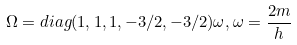<formula> <loc_0><loc_0><loc_500><loc_500>\Omega = d i a g ( 1 , 1 , 1 , - 3 / 2 , - 3 / 2 ) \omega , \omega = \frac { 2 m } { h }</formula> 